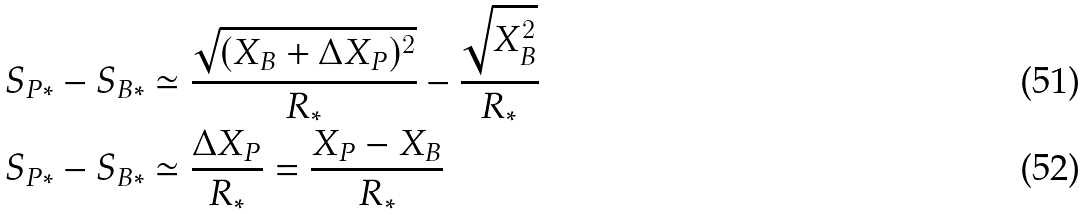Convert formula to latex. <formula><loc_0><loc_0><loc_500><loc_500>S _ { P * } - S _ { B * } & \simeq \frac { \sqrt { ( X _ { B } + \Delta X _ { P } ) ^ { 2 } } } { R _ { * } } - \frac { \sqrt { X _ { B } ^ { 2 } } } { R _ { * } } \\ S _ { P * } - S _ { B * } & \simeq \frac { \Delta X _ { P } } { R _ { * } } = \frac { X _ { P } - X _ { B } } { R _ { * } }</formula> 